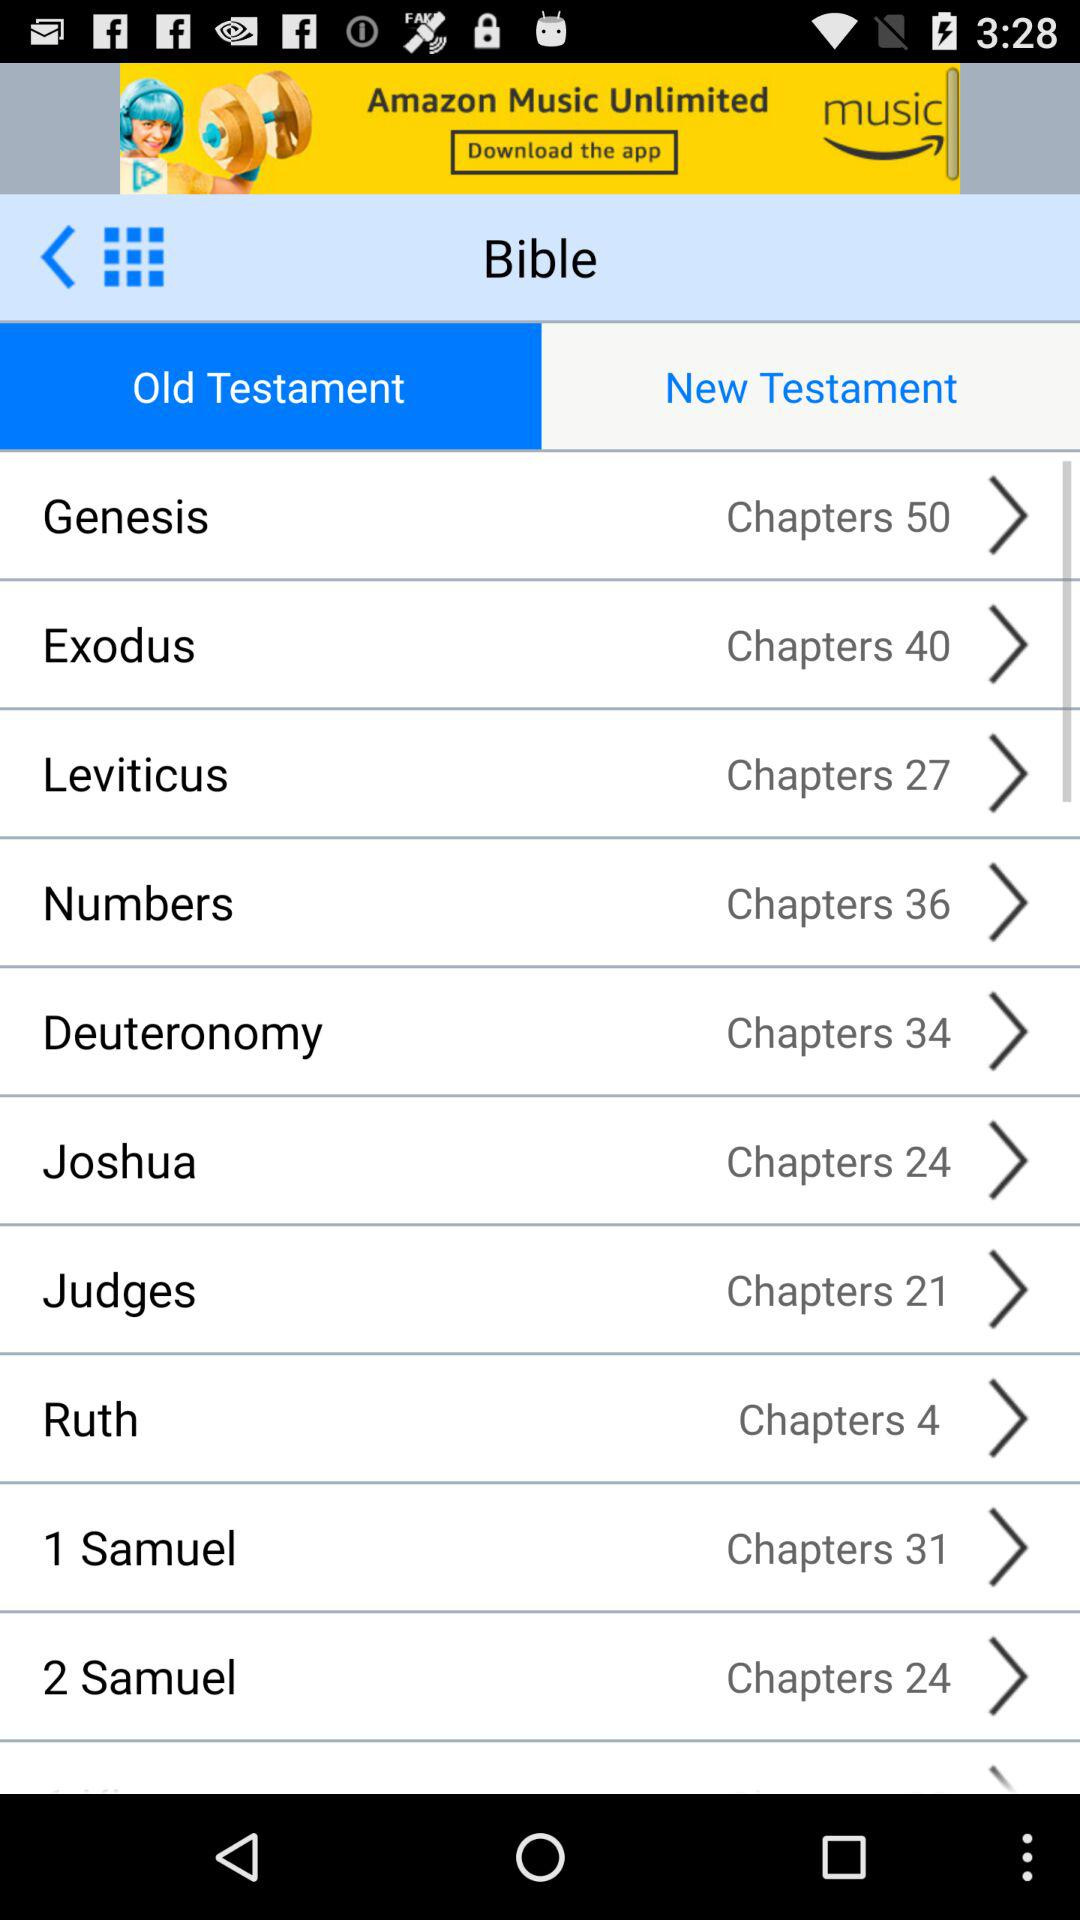How many chapters does Genesis have?
Answer the question using a single word or phrase. 50 